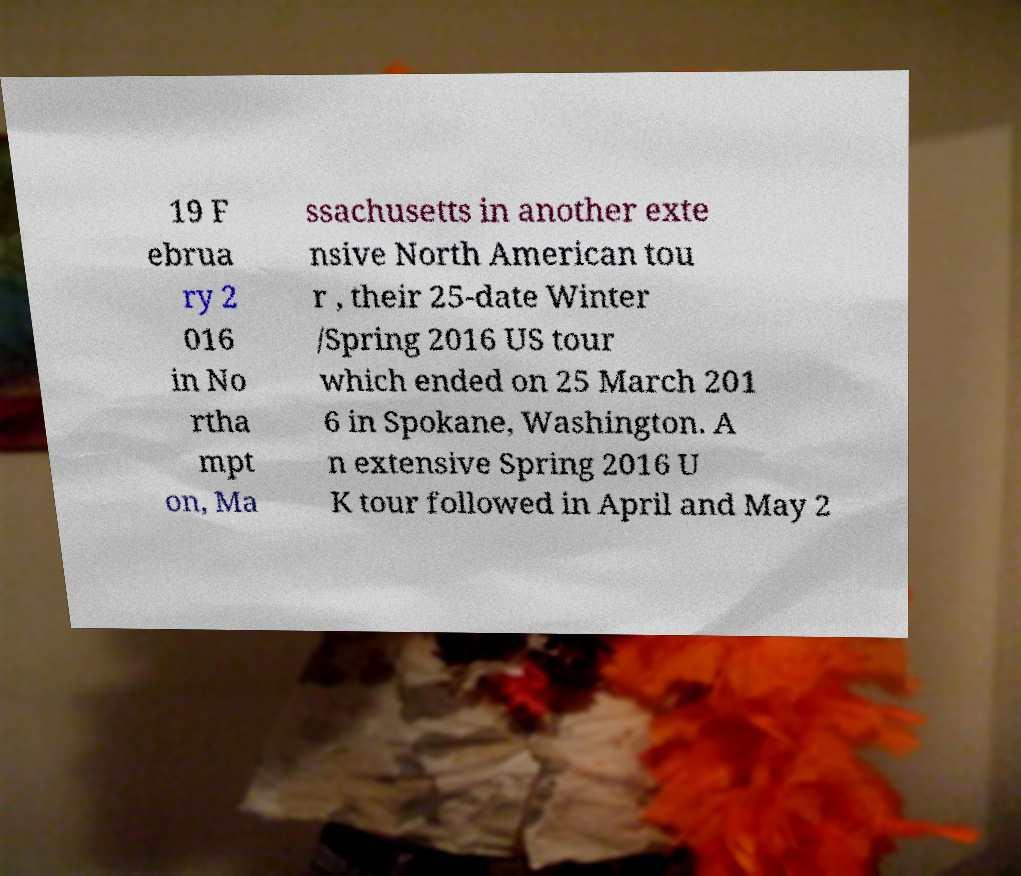Could you extract and type out the text from this image? 19 F ebrua ry 2 016 in No rtha mpt on, Ma ssachusetts in another exte nsive North American tou r , their 25-date Winter /Spring 2016 US tour which ended on 25 March 201 6 in Spokane, Washington. A n extensive Spring 2016 U K tour followed in April and May 2 